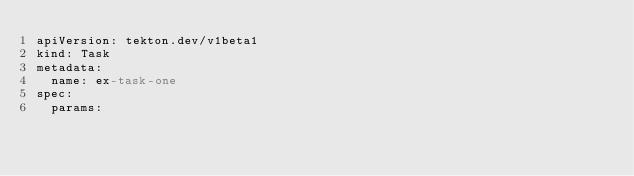<code> <loc_0><loc_0><loc_500><loc_500><_YAML_>apiVersion: tekton.dev/v1beta1
kind: Task
metadata:
  name: ex-task-one
spec:
  params:</code> 